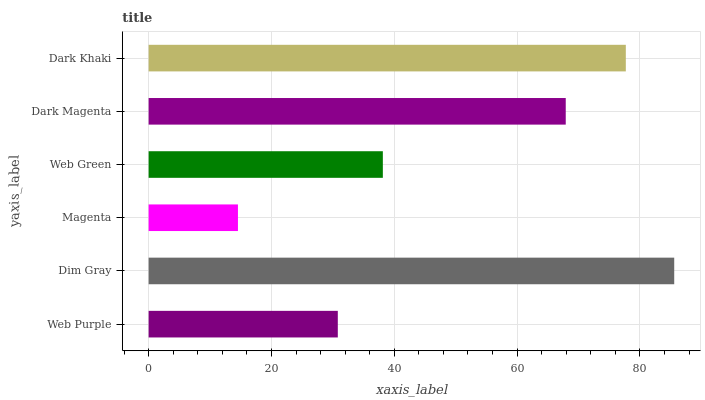Is Magenta the minimum?
Answer yes or no. Yes. Is Dim Gray the maximum?
Answer yes or no. Yes. Is Dim Gray the minimum?
Answer yes or no. No. Is Magenta the maximum?
Answer yes or no. No. Is Dim Gray greater than Magenta?
Answer yes or no. Yes. Is Magenta less than Dim Gray?
Answer yes or no. Yes. Is Magenta greater than Dim Gray?
Answer yes or no. No. Is Dim Gray less than Magenta?
Answer yes or no. No. Is Dark Magenta the high median?
Answer yes or no. Yes. Is Web Green the low median?
Answer yes or no. Yes. Is Web Purple the high median?
Answer yes or no. No. Is Web Purple the low median?
Answer yes or no. No. 